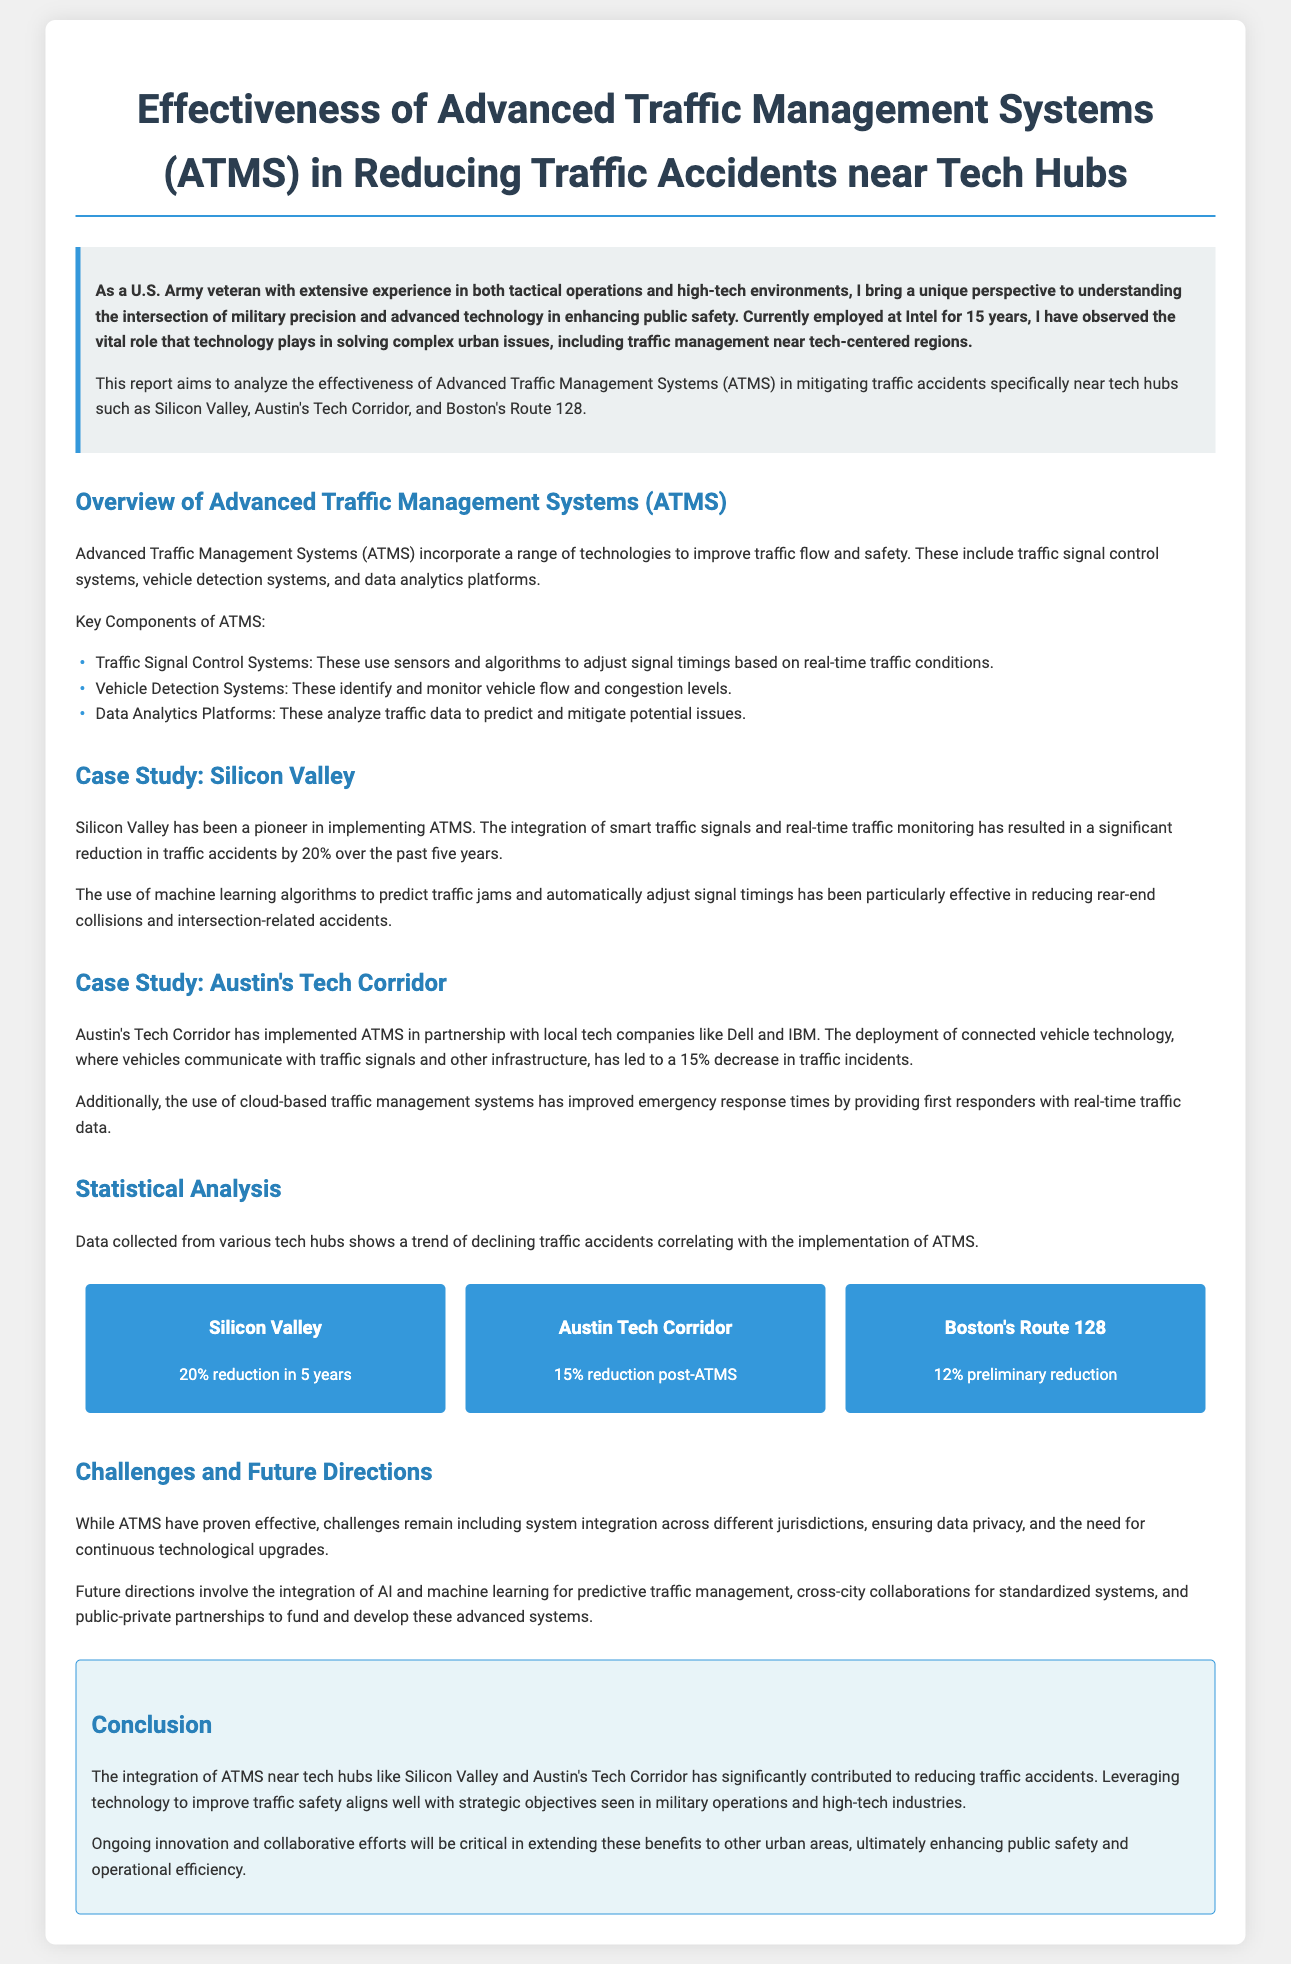What is the report about? The report analyzes the effectiveness of Advanced Traffic Management Systems (ATMS) in reducing traffic accidents near tech hubs.
Answer: Effectiveness of Advanced Traffic Management Systems (ATMS) in Reducing Traffic Accidents near Tech Hubs What percentage of traffic accidents was reduced in Silicon Valley? The document states that there was a significant reduction in traffic accidents by 20% over the past five years in Silicon Valley.
Answer: 20% Which two tech companies collaborated with Austin's Tech Corridor for ATMS? The report mentions Dell and IBM as the local tech companies that partnered with Austin's Tech Corridor for ATMS.
Answer: Dell and IBM What is the preliminary reduction of traffic incidents reported for Boston's Route 128? The document indicates a 12% preliminary reduction in traffic incidents for Boston's Route 128.
Answer: 12% What technology is used in vehicle detection systems? The document describes vehicle detection systems as technologies that identify and monitor vehicle flow and congestion levels.
Answer: Identify and monitor vehicle flow and congestion levels What are some challenges mentioned regarding ATMS? The report outlines challenges such as system integration across jurisdictions, ensuring data privacy, and the need for continuous technological upgrades.
Answer: System integration, data privacy, technological upgrades What is a notable future direction for ATMS? The document highlights the integration of AI and machine learning for predictive traffic management as a future direction for ATMS.
Answer: Integration of AI and machine learning What was the impact of connected vehicle technology in Austin's Tech Corridor? The report notes that connected vehicle technology led to a 15% decrease in traffic incidents.
Answer: 15% decrease in traffic incidents 